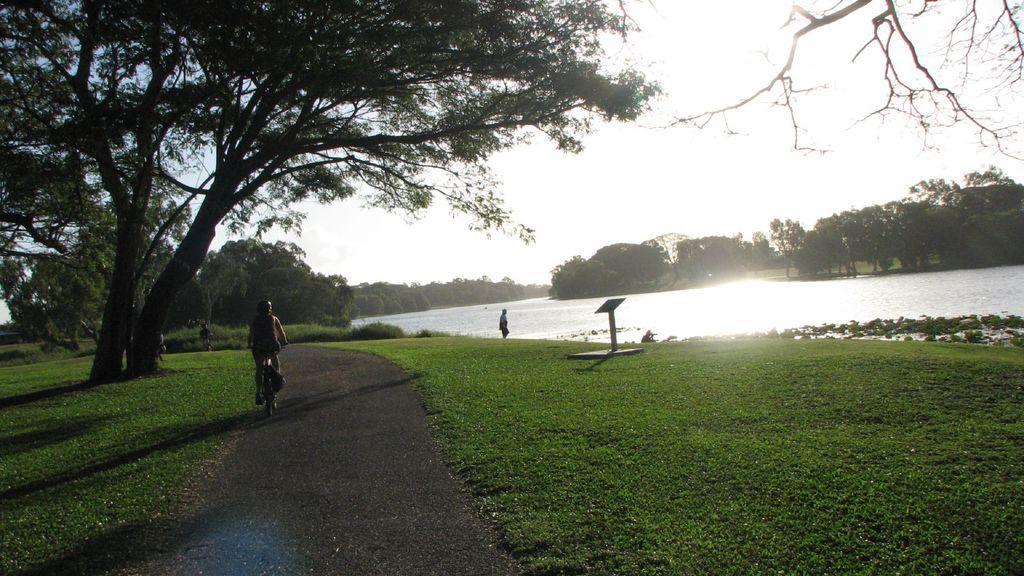In one or two sentences, can you explain what this image depicts? In this image we can see some people riding bicycles on the road. In the center of the image we can see a person standing beside a water body. We can also see a group of trees, the grass and the sky which looks cloudy. 